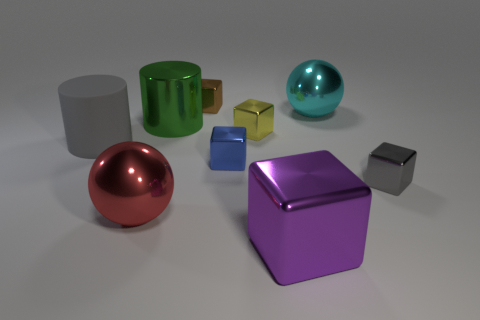Are there more large green metallic cylinders than tiny green matte spheres?
Your response must be concise. Yes. How many metallic objects are to the right of the green shiny thing and behind the big gray cylinder?
Provide a short and direct response. 3. What number of yellow shiny blocks are on the left side of the large thing that is to the left of the large red metallic object?
Ensure brevity in your answer.  0. Do the cylinder right of the large rubber cylinder and the metallic sphere that is on the right side of the small brown block have the same size?
Make the answer very short. Yes. How many large red matte cubes are there?
Your answer should be very brief. 0. How many yellow things are made of the same material as the big purple cube?
Make the answer very short. 1. Are there an equal number of big gray rubber cylinders that are in front of the tiny yellow object and red cylinders?
Give a very brief answer. No. What is the material of the other object that is the same color as the matte thing?
Offer a terse response. Metal. Do the brown cube and the metallic ball that is left of the small brown thing have the same size?
Your response must be concise. No. How many other things are there of the same size as the purple object?
Give a very brief answer. 4. 